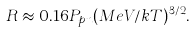Convert formula to latex. <formula><loc_0><loc_0><loc_500><loc_500>R \approx 0 . 1 6 P _ { p n } ( M e V / k T ) ^ { 3 / 2 } .</formula> 